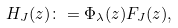<formula> <loc_0><loc_0><loc_500><loc_500>H _ { J } ( z ) \colon = \Phi _ { \lambda } ( z ) F _ { J } ( z ) ,</formula> 